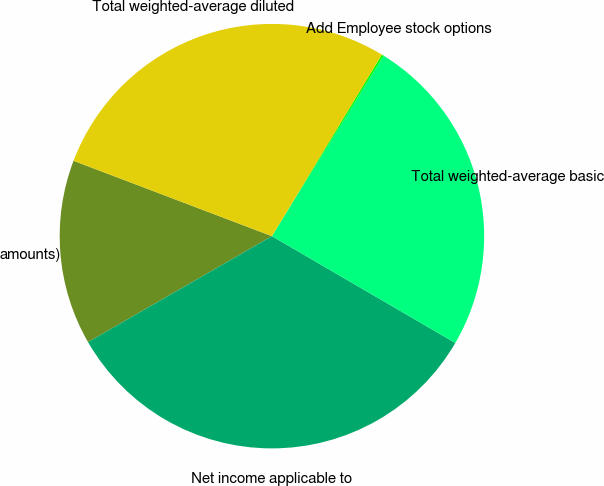<chart> <loc_0><loc_0><loc_500><loc_500><pie_chart><fcel>amounts)<fcel>Net income applicable to<fcel>Total weighted-average basic<fcel>Add Employee stock options<fcel>Total weighted-average diluted<nl><fcel>14.1%<fcel>33.29%<fcel>24.58%<fcel>0.15%<fcel>27.89%<nl></chart> 